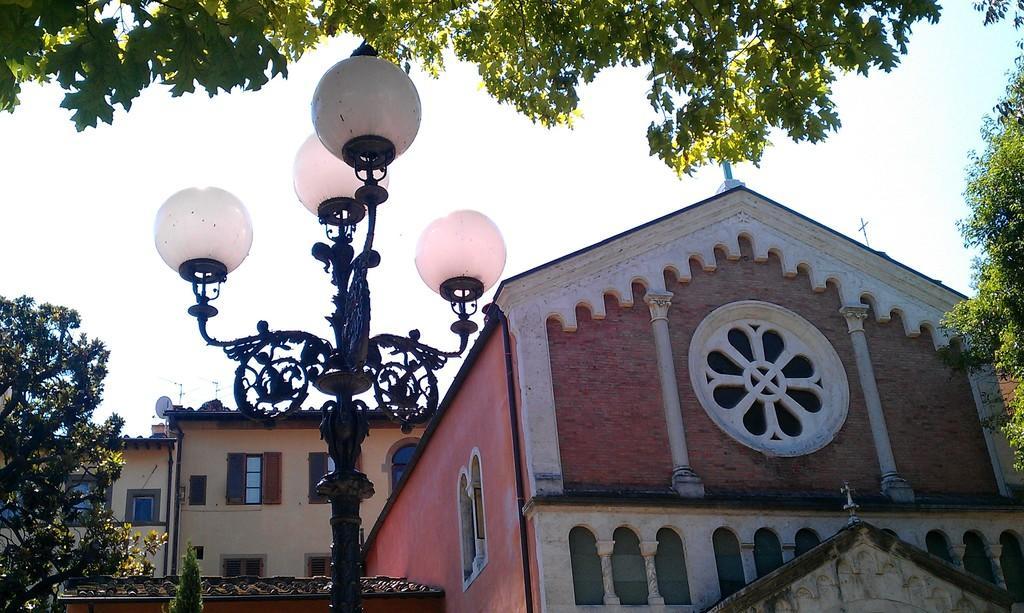Describe this image in one or two sentences. This picture is taken from the outside of the building. In this image, on the left side, we can see a street light. On the left side, we can see some trees. On the left side, we can see a glass window. On the right side, we can see some trees. At the top, we can see a sky and trees. 